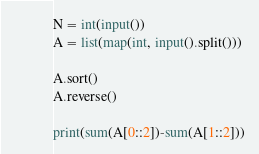Convert code to text. <code><loc_0><loc_0><loc_500><loc_500><_Python_>N = int(input())
A = list(map(int, input().split()))

A.sort()
A.reverse()

print(sum(A[0::2])-sum(A[1::2]))</code> 